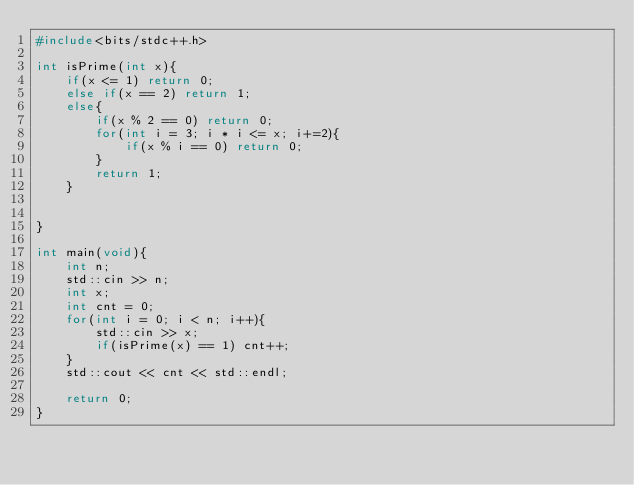Convert code to text. <code><loc_0><loc_0><loc_500><loc_500><_C++_>#include<bits/stdc++.h>

int isPrime(int x){
    if(x <= 1) return 0;
    else if(x == 2) return 1;
    else{
        if(x % 2 == 0) return 0;
        for(int i = 3; i * i <= x; i+=2){
            if(x % i == 0) return 0;
        }
        return 1;
    }
    

}

int main(void){
    int n;
    std::cin >> n;
    int x;
    int cnt = 0;
    for(int i = 0; i < n; i++){
        std::cin >> x;
        if(isPrime(x) == 1) cnt++;
    }
    std::cout << cnt << std::endl;

    return 0;
}
</code> 